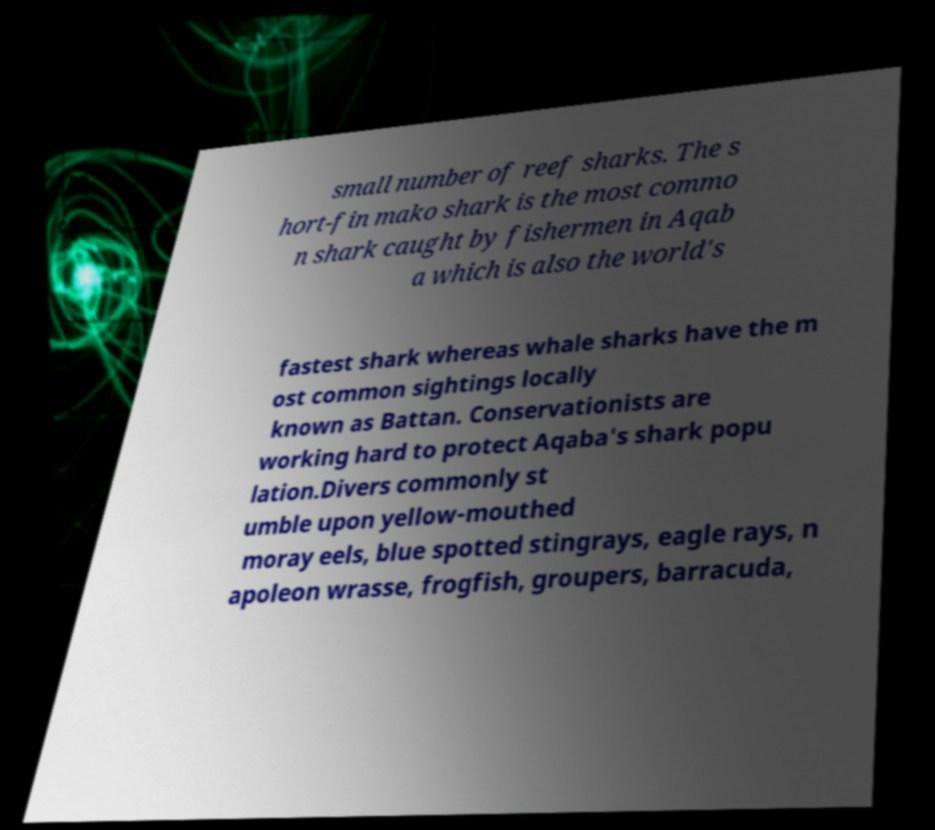There's text embedded in this image that I need extracted. Can you transcribe it verbatim? small number of reef sharks. The s hort-fin mako shark is the most commo n shark caught by fishermen in Aqab a which is also the world's fastest shark whereas whale sharks have the m ost common sightings locally known as Battan. Conservationists are working hard to protect Aqaba's shark popu lation.Divers commonly st umble upon yellow-mouthed moray eels, blue spotted stingrays, eagle rays, n apoleon wrasse, frogfish, groupers, barracuda, 